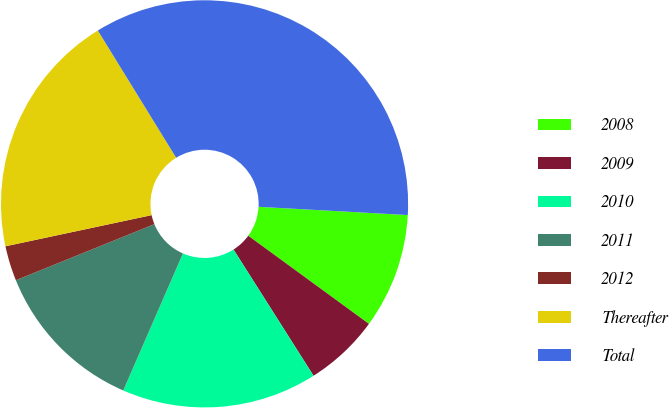<chart> <loc_0><loc_0><loc_500><loc_500><pie_chart><fcel>2008<fcel>2009<fcel>2010<fcel>2011<fcel>2012<fcel>Thereafter<fcel>Total<nl><fcel>9.16%<fcel>5.97%<fcel>15.53%<fcel>12.34%<fcel>2.78%<fcel>19.56%<fcel>34.66%<nl></chart> 